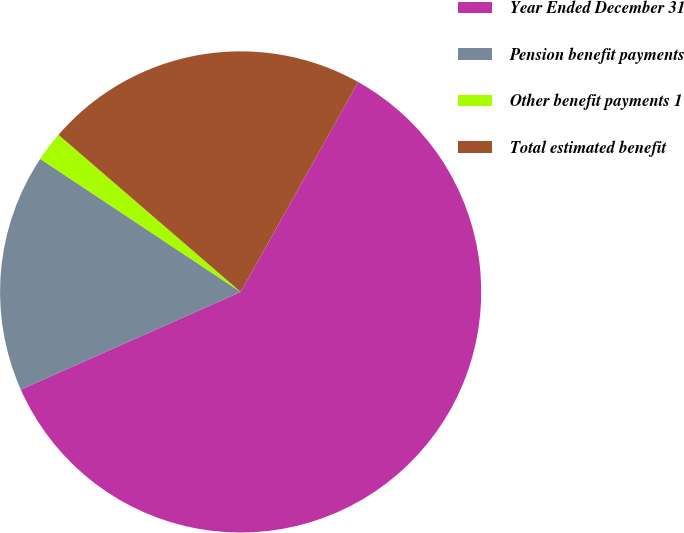<chart> <loc_0><loc_0><loc_500><loc_500><pie_chart><fcel>Year Ended December 31<fcel>Pension benefit payments<fcel>Other benefit payments 1<fcel>Total estimated benefit<nl><fcel>60.22%<fcel>15.98%<fcel>2.0%<fcel>21.8%<nl></chart> 